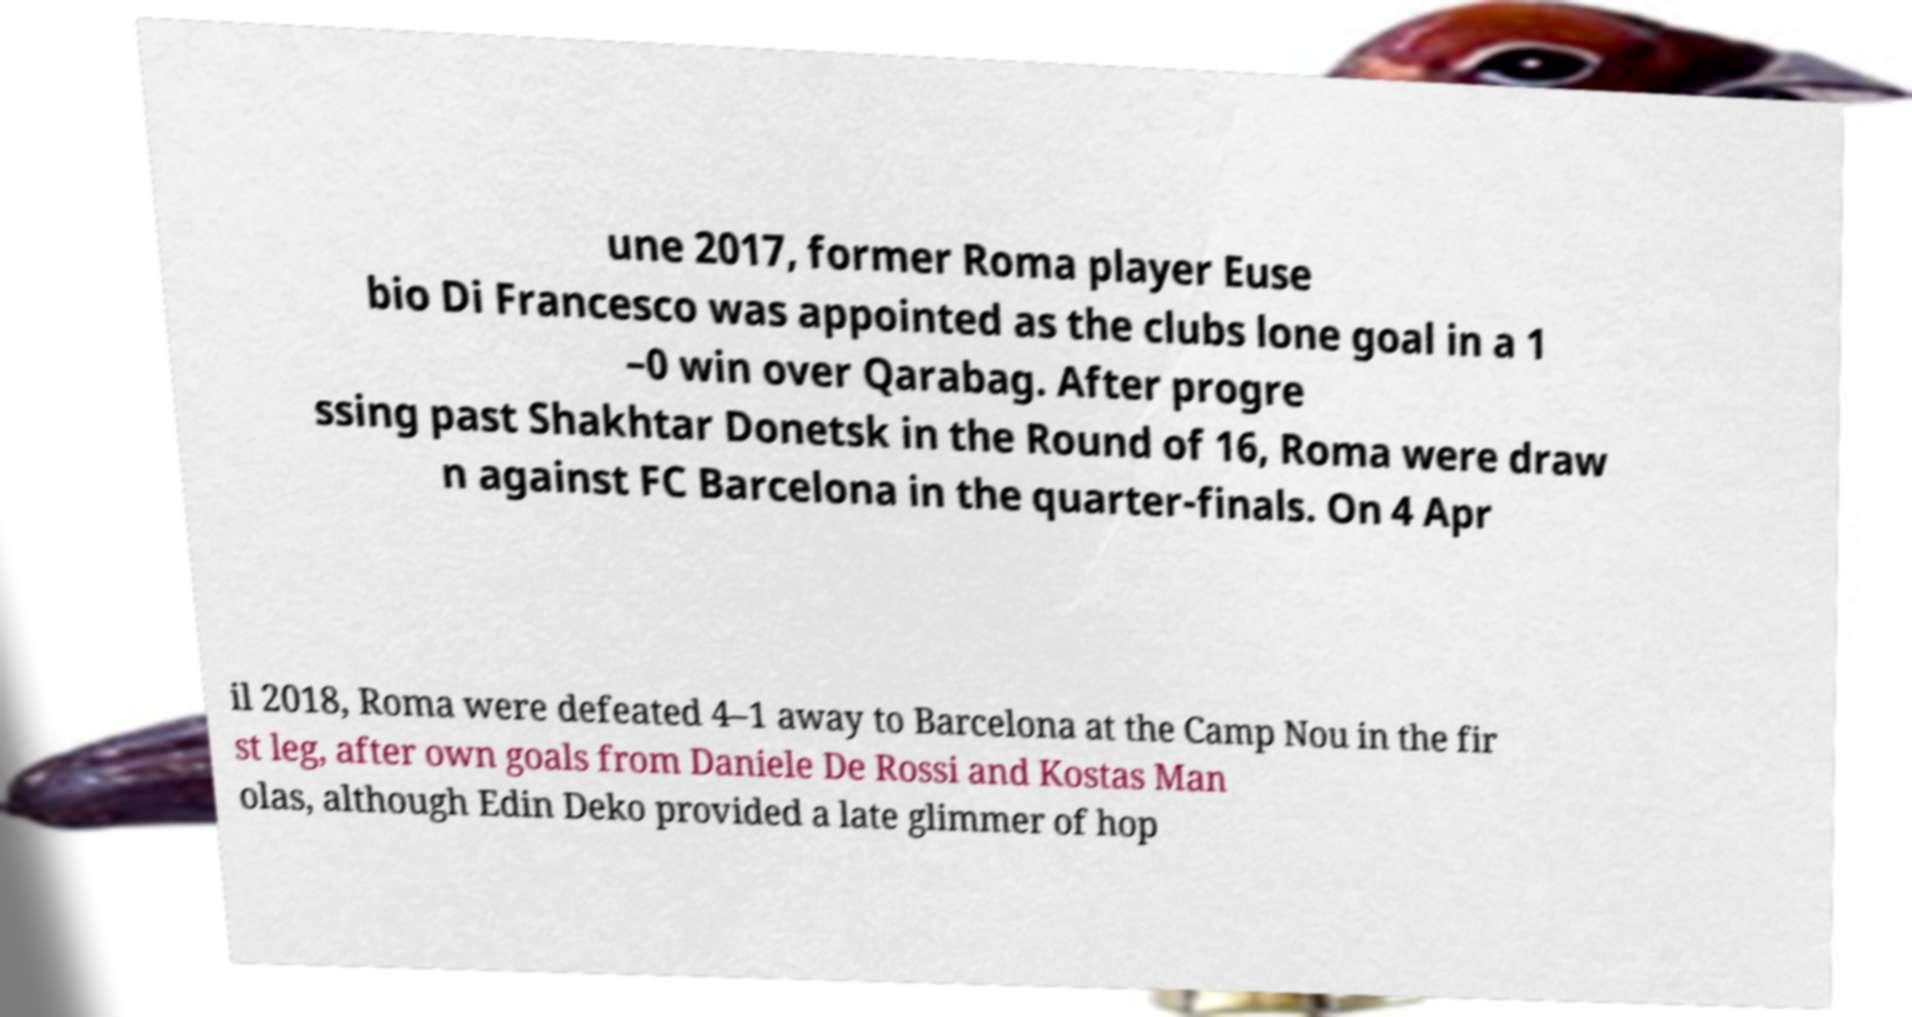Could you assist in decoding the text presented in this image and type it out clearly? une 2017, former Roma player Euse bio Di Francesco was appointed as the clubs lone goal in a 1 –0 win over Qarabag. After progre ssing past Shakhtar Donetsk in the Round of 16, Roma were draw n against FC Barcelona in the quarter-finals. On 4 Apr il 2018, Roma were defeated 4–1 away to Barcelona at the Camp Nou in the fir st leg, after own goals from Daniele De Rossi and Kostas Man olas, although Edin Deko provided a late glimmer of hop 